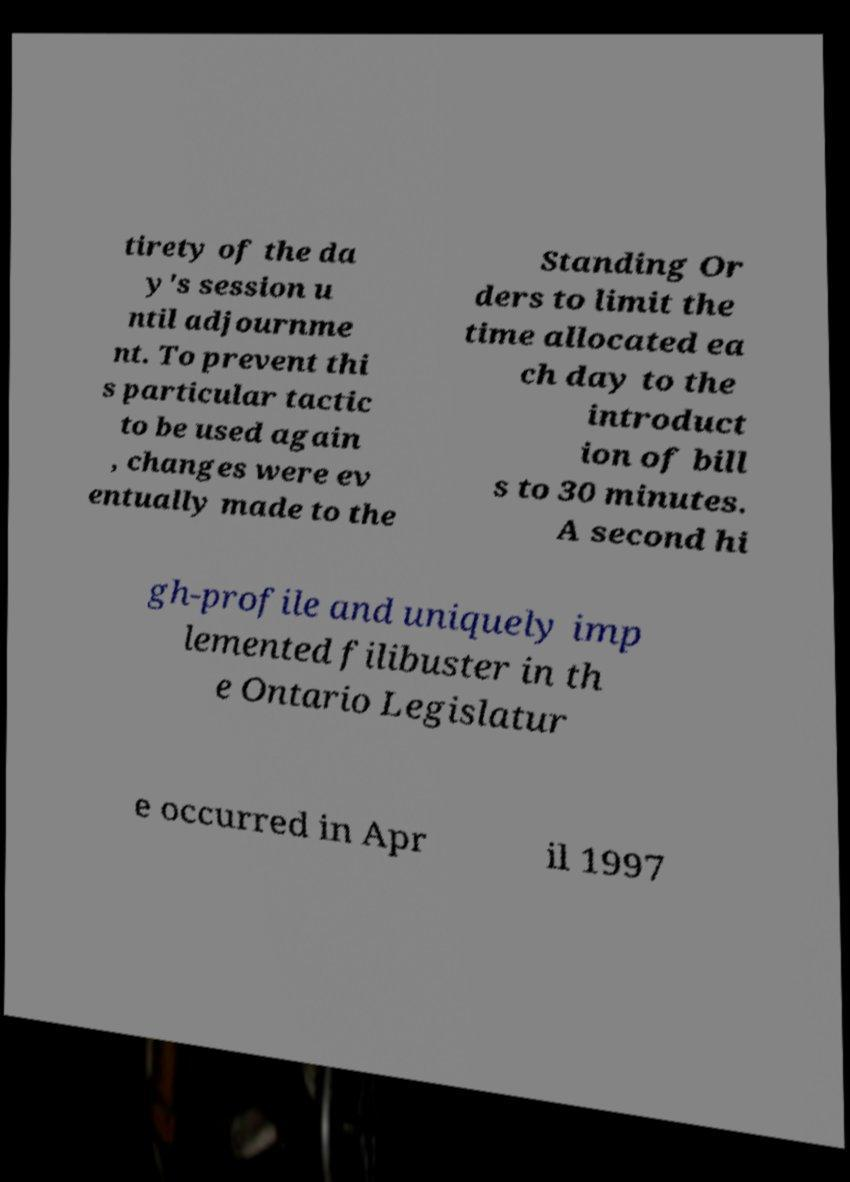Can you accurately transcribe the text from the provided image for me? tirety of the da y's session u ntil adjournme nt. To prevent thi s particular tactic to be used again , changes were ev entually made to the Standing Or ders to limit the time allocated ea ch day to the introduct ion of bill s to 30 minutes. A second hi gh-profile and uniquely imp lemented filibuster in th e Ontario Legislatur e occurred in Apr il 1997 